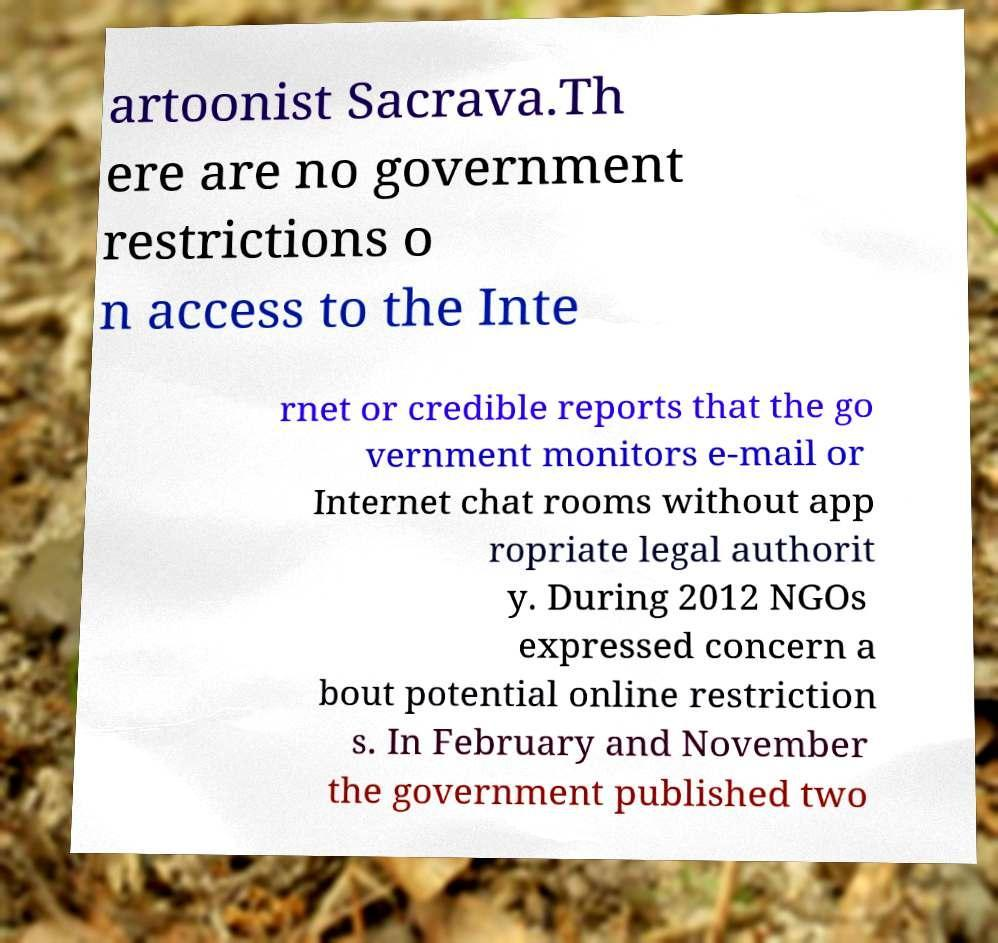Could you extract and type out the text from this image? artoonist Sacrava.Th ere are no government restrictions o n access to the Inte rnet or credible reports that the go vernment monitors e-mail or Internet chat rooms without app ropriate legal authorit y. During 2012 NGOs expressed concern a bout potential online restriction s. In February and November the government published two 